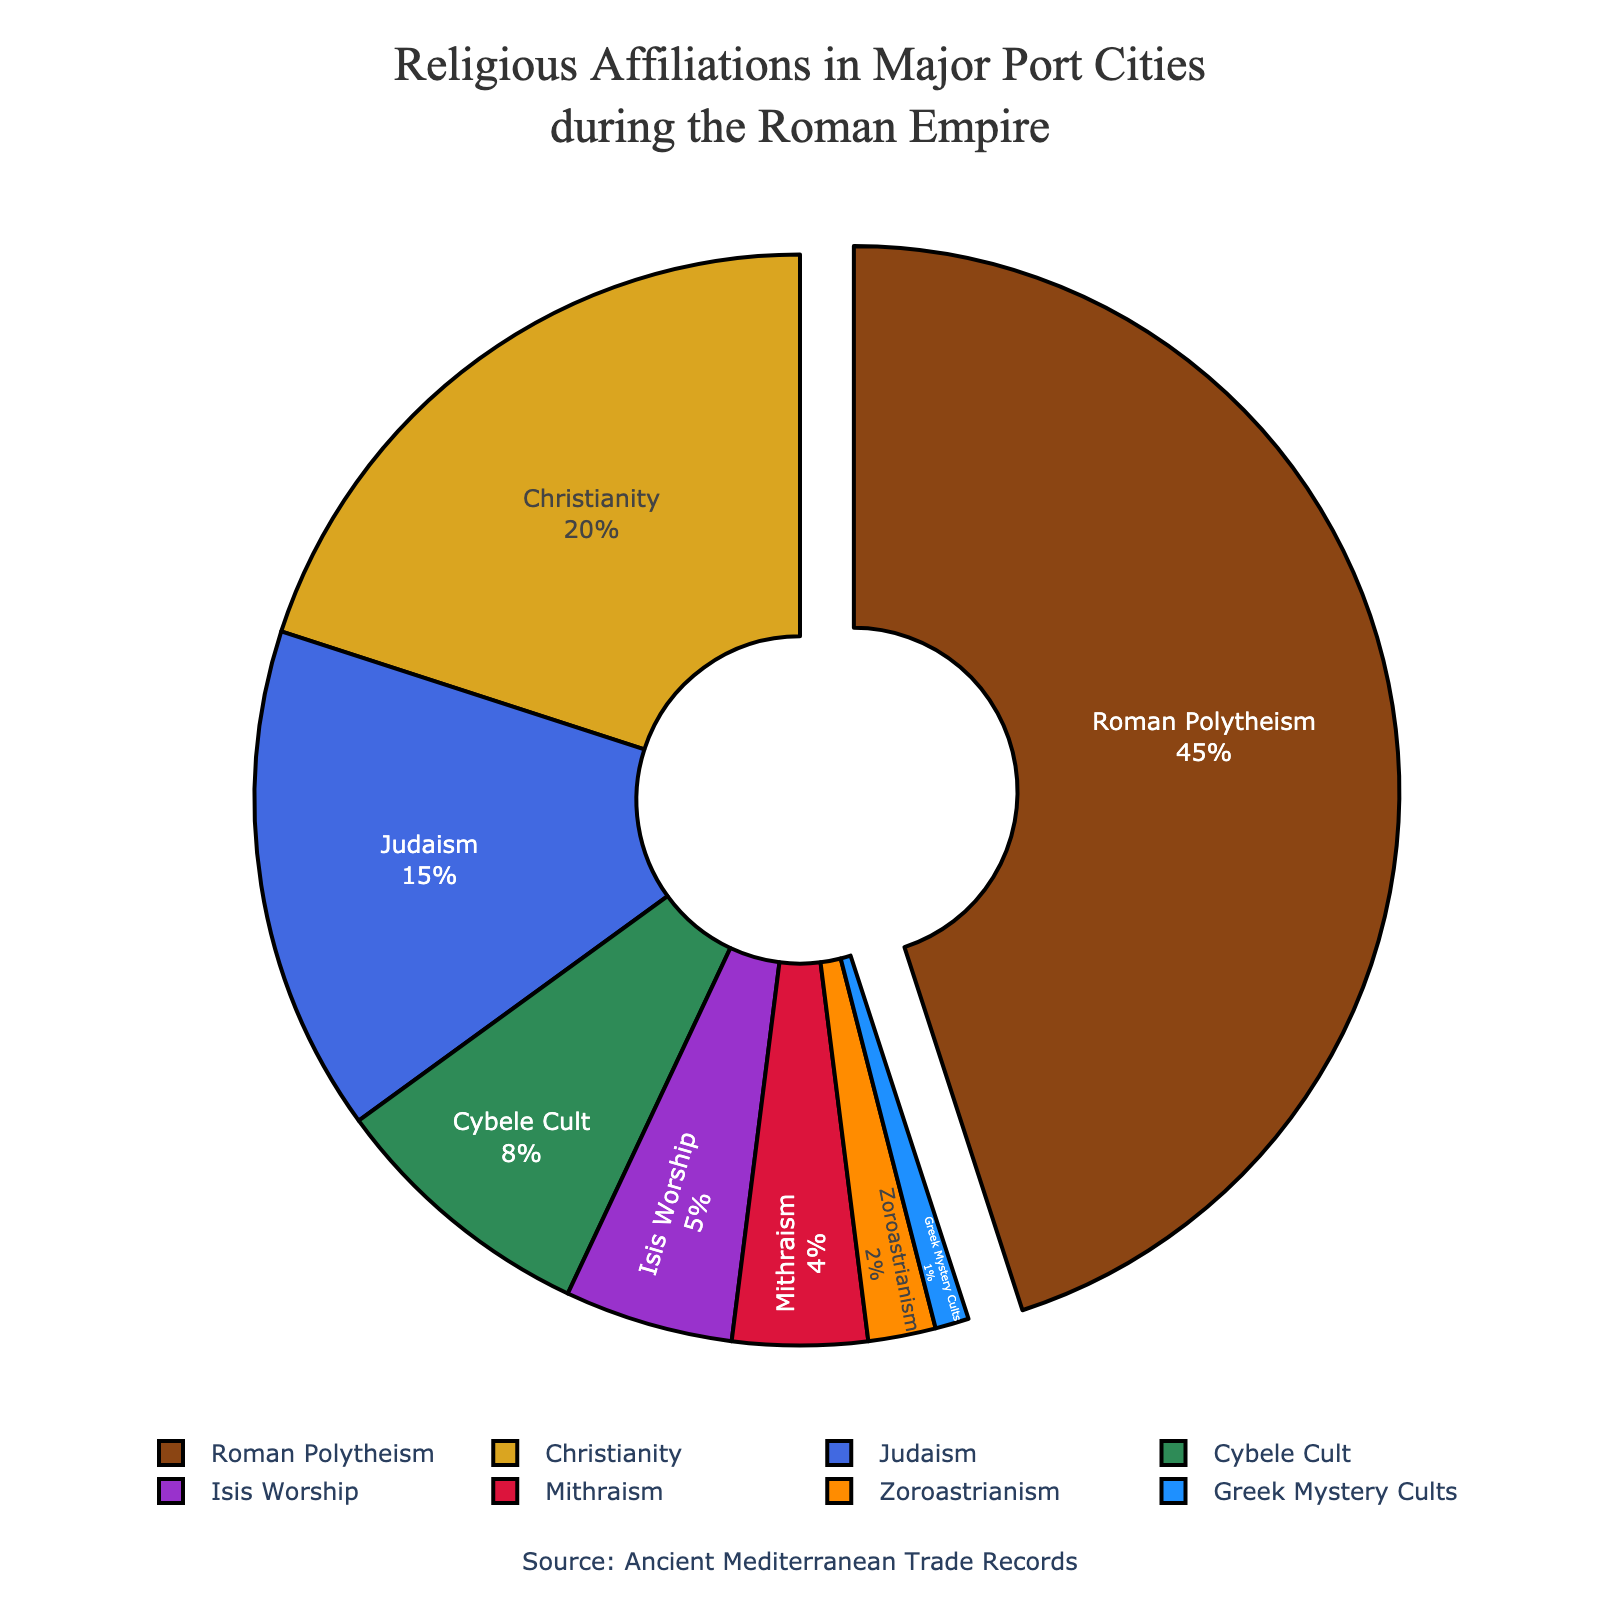What is the most prevalent religion in major port cities during the Roman Empire? The pie chart shows various religions with their respective percentages. The highest percentage slice is clearly Roman Polytheism at 45%.
Answer: Roman Polytheism Which religion has the smallest representation in the major port cities? The smallest slice on the pie chart is for Greek Mystery Cults, which holds only 1% of the religious affiliations.
Answer: Greek Mystery Cults Compare Christianity and Judaism in terms of their percentage representation. Which one has a larger share? The pie chart shows that Christianity has a 20% representation while Judaism has a 15% representation. Hence, Christianity has a larger share.
Answer: Christianity What percentage of the population in major port cities adhered to Roman Polytheism and Christianity combined? The pie chart shows Roman Polytheism at 45% and Christianity at 20%. Adding these gives 45% + 20% = 65%.
Answer: 65% How does the representation of Cybele Cult compare to that of Isis Worship? The pie chart indicates that Cybele Cult has an 8% representation while Isis Worship has a 5% representation. Therefore, Cybele Cult has a larger share.
Answer: Cybele Cult What is the total percentage of religions other than Roman Polytheism? Subtract the percentage of Roman Polytheism from 100%. That is 100% - 45% = 55%.
Answer: 55% If we combine the percentages of Judaism, Cybele Cult, and Mithraism, what total percentage do we get? According to the pie chart, Judaism is 15%, Cybele Cult is 8%, and Mithraism is 4%. Adding these together gives 15% + 8% + 4% = 27%.
Answer: 27% Which religion's percentage is the mean of the percentages of Mithraism and Zoroastrianism? Mithraism has 4% and Zoroastrianism has 2%. Their mean is (4% + 2%) / 2 = 3%. None of the religions exactly match 3%, so the mean does not directly correspond to any single religion on the pie chart.
Answer: None Identify the second and third most prevalent religions in the chart and their respective percentages. The second most prevalent religion is Christianity at 20%, and the third most prevalent religion is Judaism at 15%.
Answer: Christianity (20%), Judaism (15%) What is the percentage difference between the two least represented religions? The two least represented religions are Greek Mystery Cults (1%) and Zoroastrianism (2%). The difference is 2% - 1% = 1%.
Answer: 1% 